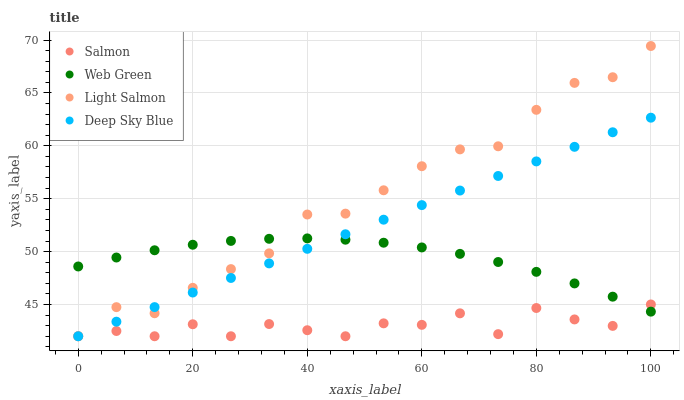Does Salmon have the minimum area under the curve?
Answer yes or no. Yes. Does Light Salmon have the maximum area under the curve?
Answer yes or no. Yes. Does Deep Sky Blue have the minimum area under the curve?
Answer yes or no. No. Does Deep Sky Blue have the maximum area under the curve?
Answer yes or no. No. Is Deep Sky Blue the smoothest?
Answer yes or no. Yes. Is Salmon the roughest?
Answer yes or no. Yes. Is Salmon the smoothest?
Answer yes or no. No. Is Deep Sky Blue the roughest?
Answer yes or no. No. Does Light Salmon have the lowest value?
Answer yes or no. Yes. Does Web Green have the lowest value?
Answer yes or no. No. Does Light Salmon have the highest value?
Answer yes or no. Yes. Does Deep Sky Blue have the highest value?
Answer yes or no. No. Does Deep Sky Blue intersect Web Green?
Answer yes or no. Yes. Is Deep Sky Blue less than Web Green?
Answer yes or no. No. Is Deep Sky Blue greater than Web Green?
Answer yes or no. No. 